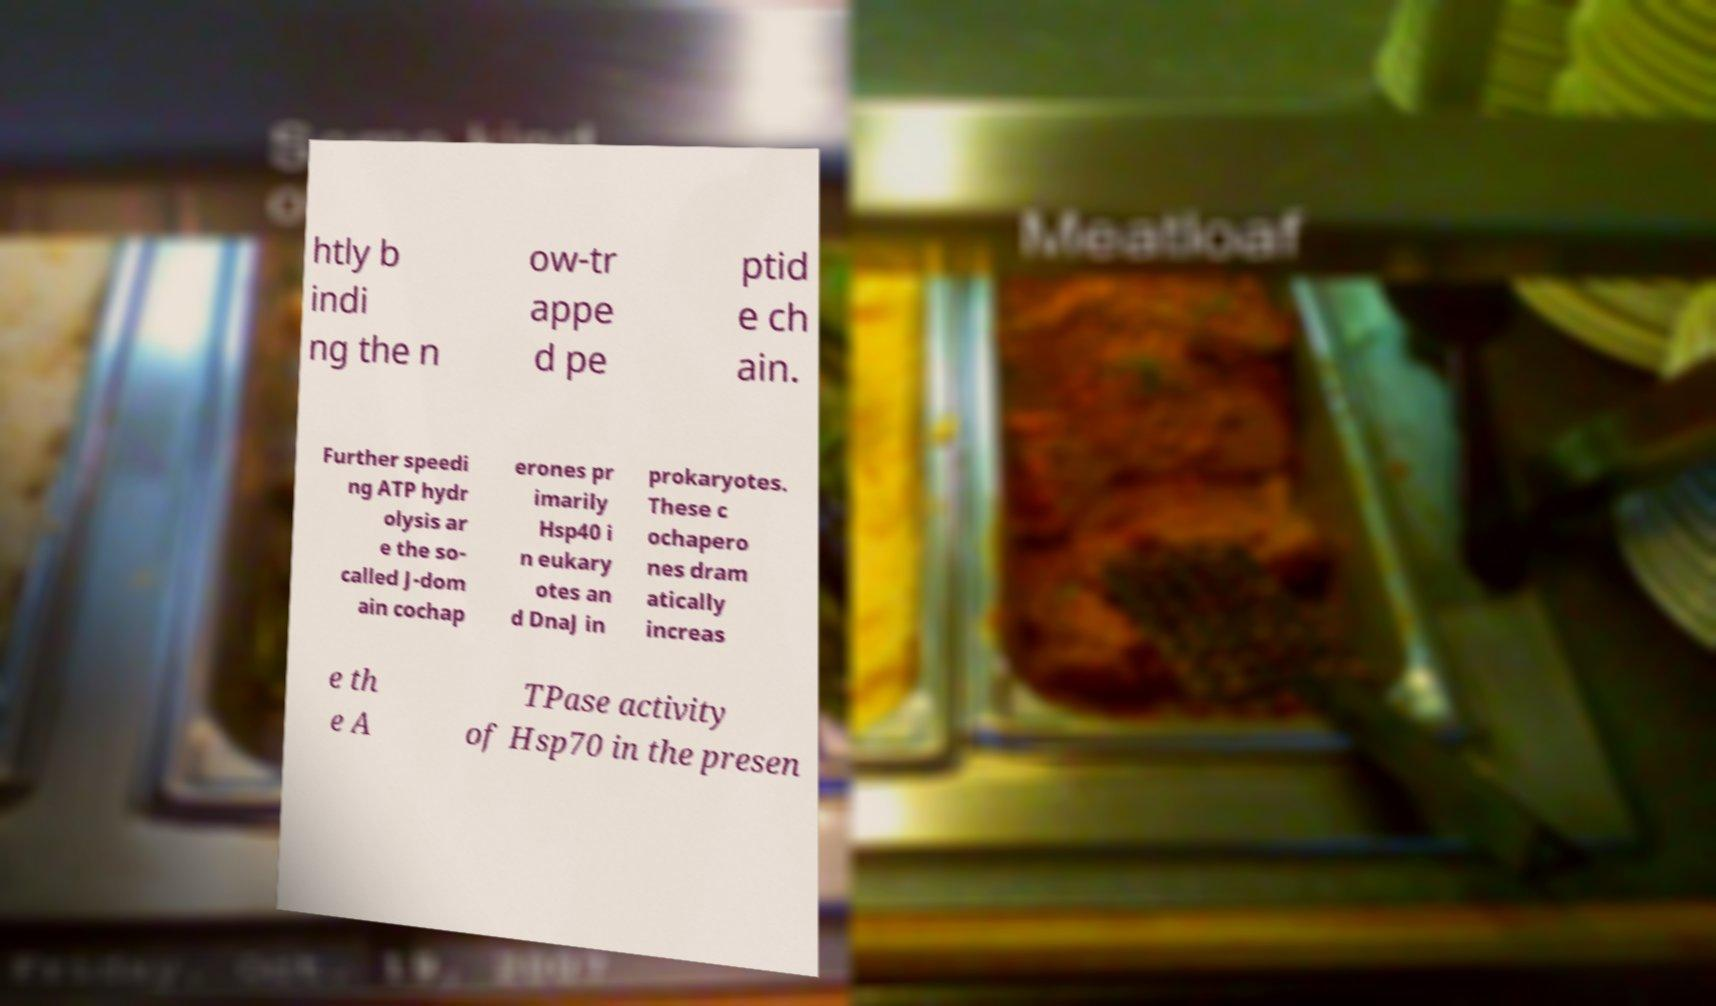Please read and relay the text visible in this image. What does it say? htly b indi ng the n ow-tr appe d pe ptid e ch ain. Further speedi ng ATP hydr olysis ar e the so- called J-dom ain cochap erones pr imarily Hsp40 i n eukary otes an d DnaJ in prokaryotes. These c ochapero nes dram atically increas e th e A TPase activity of Hsp70 in the presen 